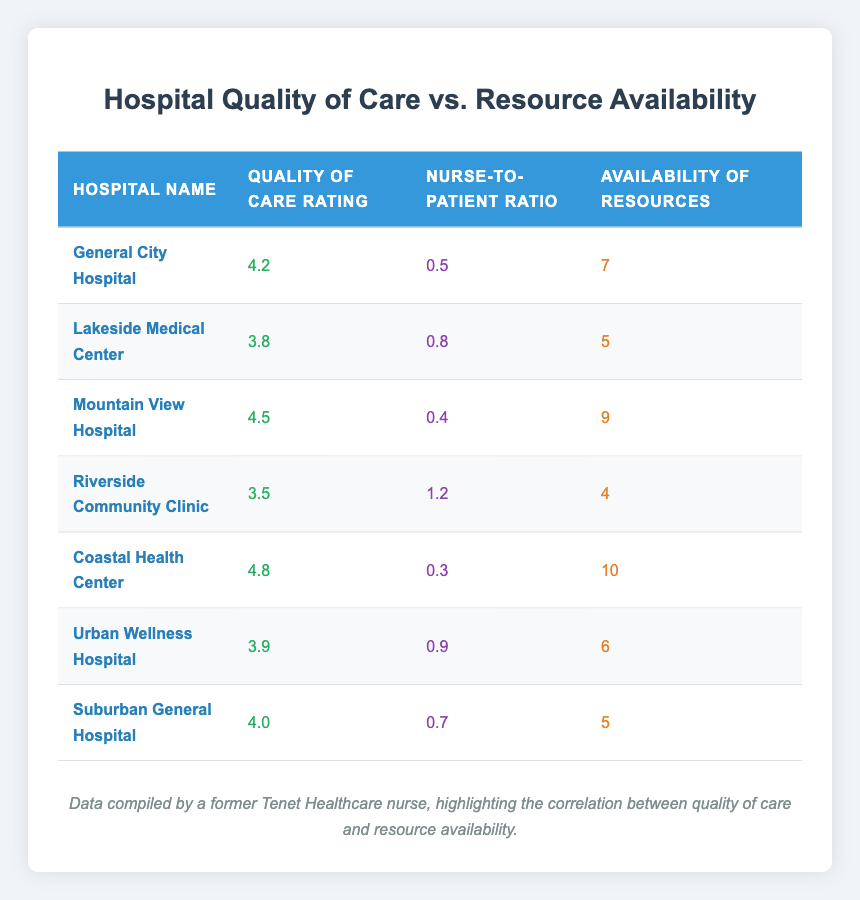What is the quality of care rating for Coastal Health Center? Coastal Health Center has a quality of care rating listed in the table, which is 4.8.
Answer: 4.8 Which hospital has the lowest quality of care rating? By comparing the quality of care ratings of all hospitals in the table, Riverside Community Clinic has the lowest rating at 3.5.
Answer: Riverside Community Clinic What is the availability of resources for Mountain View Hospital? The availability of resources for Mountain View Hospital is given in the table as 9.
Answer: 9 What is the average quality of care rating for the hospitals in this table? The total quality of care ratings are (4.2 + 3.8 + 4.5 + 3.5 + 4.8 + 3.9 + 4.0) = 28.7. There are 7 hospitals, so the average is 28.7 / 7 = 4.1.
Answer: 4.1 Is there a hospital in the table with a nurse-to-patient ratio of 1.0 or higher? By examining the nurse-to-patient ratios, Riverside Community Clinic has a ratio of 1.2, which is indeed 1.0 or higher, thus there is a hospital that meets this criterion.
Answer: Yes Which hospital has the best availability of resources? The table shows that Coastal Health Center has the best availability of resources with a score of 10.
Answer: Coastal Health Center Is there a correlation between higher nurse-to-patient ratios and quality of care ratings? By analyzing the data, Riverside Community Clinic has the highest nurse-to-patient ratio of 1.2 and the lowest quality of care rating of 3.5. In contrast, Coastal Health Center has the lowest nurse-to-patient ratio of 0.3 and the highest quality of care rating of 4.8. This indicates a negative correlation between the two.
Answer: Yes What is the total number of hospitals listed in the table? The table lists a total of 7 hospitals as shown in the data provided.
Answer: 7 What is the difference in the availability of resources between General City Hospital and Urban Wellness Hospital? General City Hospital has an availability score of 7 while Urban Wellness Hospital has 6. The difference is 7 - 6 = 1.
Answer: 1 